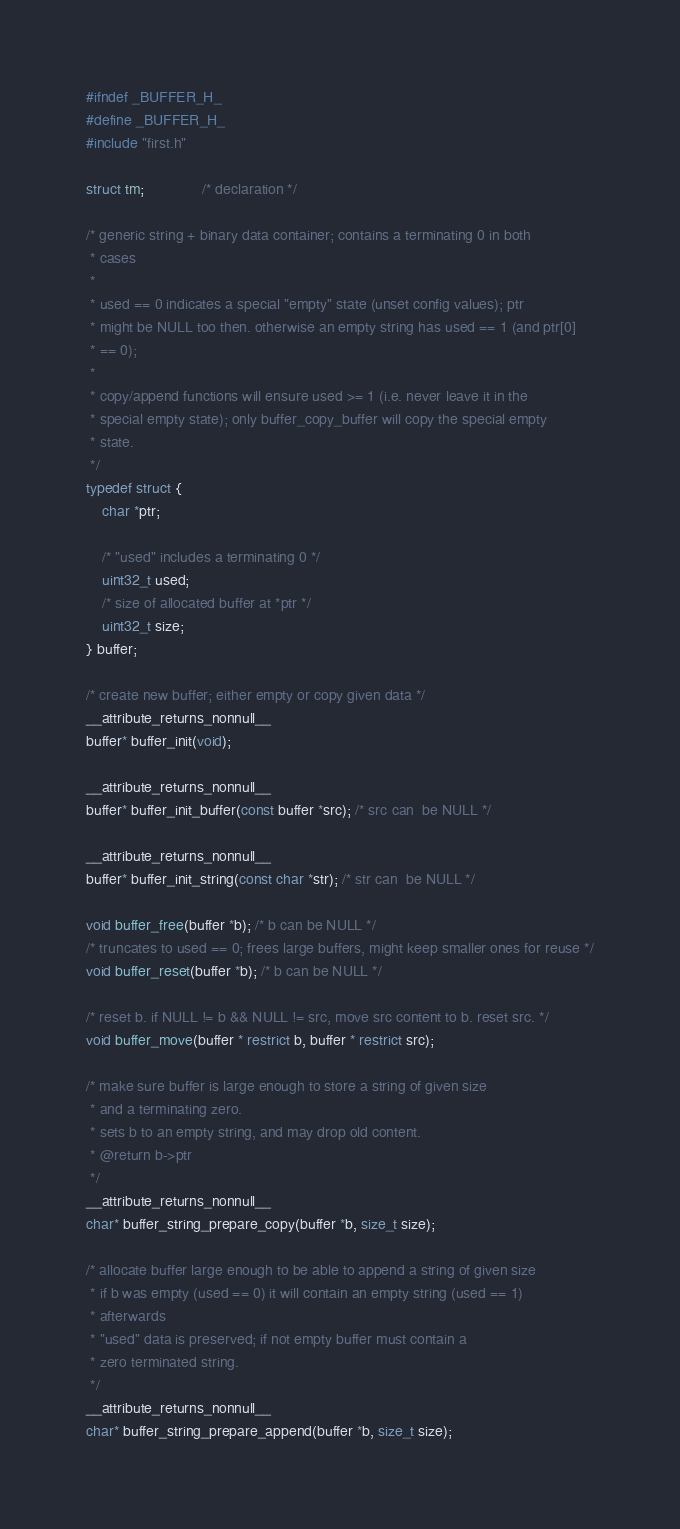<code> <loc_0><loc_0><loc_500><loc_500><_C_>#ifndef _BUFFER_H_
#define _BUFFER_H_
#include "first.h"

struct tm;              /* declaration */

/* generic string + binary data container; contains a terminating 0 in both
 * cases
 *
 * used == 0 indicates a special "empty" state (unset config values); ptr
 * might be NULL too then. otherwise an empty string has used == 1 (and ptr[0]
 * == 0);
 *
 * copy/append functions will ensure used >= 1 (i.e. never leave it in the
 * special empty state); only buffer_copy_buffer will copy the special empty
 * state.
 */
typedef struct {
	char *ptr;

	/* "used" includes a terminating 0 */
	uint32_t used;
	/* size of allocated buffer at *ptr */
	uint32_t size;
} buffer;

/* create new buffer; either empty or copy given data */
__attribute_returns_nonnull__
buffer* buffer_init(void);

__attribute_returns_nonnull__
buffer* buffer_init_buffer(const buffer *src); /* src can  be NULL */

__attribute_returns_nonnull__
buffer* buffer_init_string(const char *str); /* str can  be NULL */

void buffer_free(buffer *b); /* b can be NULL */
/* truncates to used == 0; frees large buffers, might keep smaller ones for reuse */
void buffer_reset(buffer *b); /* b can be NULL */

/* reset b. if NULL != b && NULL != src, move src content to b. reset src. */
void buffer_move(buffer * restrict b, buffer * restrict src);

/* make sure buffer is large enough to store a string of given size
 * and a terminating zero.
 * sets b to an empty string, and may drop old content.
 * @return b->ptr
 */
__attribute_returns_nonnull__
char* buffer_string_prepare_copy(buffer *b, size_t size);

/* allocate buffer large enough to be able to append a string of given size
 * if b was empty (used == 0) it will contain an empty string (used == 1)
 * afterwards
 * "used" data is preserved; if not empty buffer must contain a
 * zero terminated string.
 */
__attribute_returns_nonnull__
char* buffer_string_prepare_append(buffer *b, size_t size);
</code> 